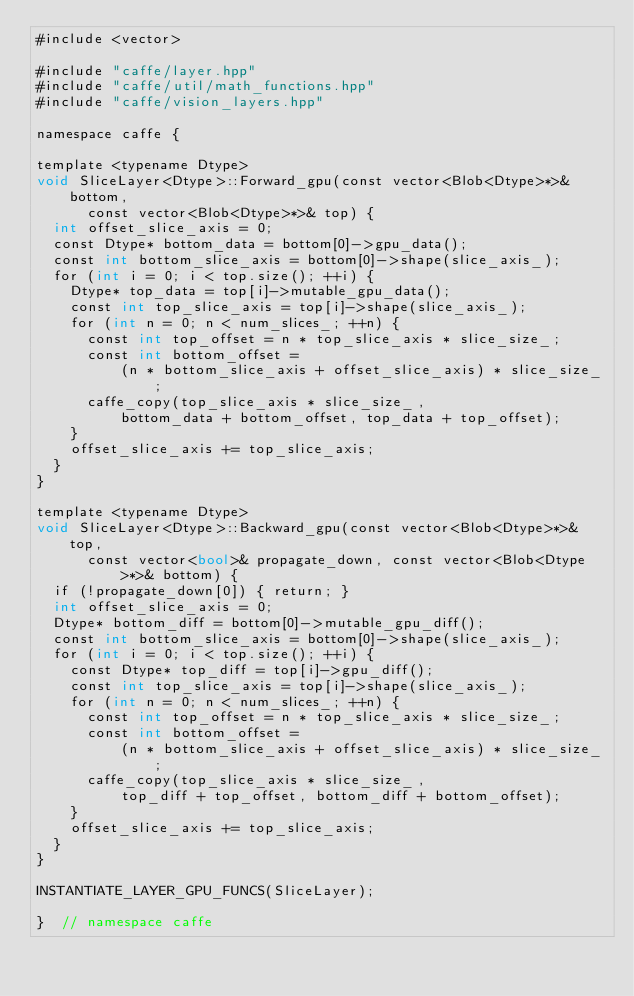Convert code to text. <code><loc_0><loc_0><loc_500><loc_500><_Cuda_>#include <vector>

#include "caffe/layer.hpp"
#include "caffe/util/math_functions.hpp"
#include "caffe/vision_layers.hpp"

namespace caffe {

template <typename Dtype>
void SliceLayer<Dtype>::Forward_gpu(const vector<Blob<Dtype>*>& bottom,
      const vector<Blob<Dtype>*>& top) {
  int offset_slice_axis = 0;
  const Dtype* bottom_data = bottom[0]->gpu_data();
  const int bottom_slice_axis = bottom[0]->shape(slice_axis_);
  for (int i = 0; i < top.size(); ++i) {
    Dtype* top_data = top[i]->mutable_gpu_data();
    const int top_slice_axis = top[i]->shape(slice_axis_);
    for (int n = 0; n < num_slices_; ++n) {
      const int top_offset = n * top_slice_axis * slice_size_;
      const int bottom_offset =
          (n * bottom_slice_axis + offset_slice_axis) * slice_size_;
      caffe_copy(top_slice_axis * slice_size_,
          bottom_data + bottom_offset, top_data + top_offset);
    }
    offset_slice_axis += top_slice_axis;
  }
}

template <typename Dtype>
void SliceLayer<Dtype>::Backward_gpu(const vector<Blob<Dtype>*>& top,
      const vector<bool>& propagate_down, const vector<Blob<Dtype>*>& bottom) {
  if (!propagate_down[0]) { return; }
  int offset_slice_axis = 0;
  Dtype* bottom_diff = bottom[0]->mutable_gpu_diff();
  const int bottom_slice_axis = bottom[0]->shape(slice_axis_);
  for (int i = 0; i < top.size(); ++i) {
    const Dtype* top_diff = top[i]->gpu_diff();
    const int top_slice_axis = top[i]->shape(slice_axis_);
    for (int n = 0; n < num_slices_; ++n) {
      const int top_offset = n * top_slice_axis * slice_size_;
      const int bottom_offset =
          (n * bottom_slice_axis + offset_slice_axis) * slice_size_;
      caffe_copy(top_slice_axis * slice_size_,
          top_diff + top_offset, bottom_diff + bottom_offset);
    }
    offset_slice_axis += top_slice_axis;
  }
}

INSTANTIATE_LAYER_GPU_FUNCS(SliceLayer);

}  // namespace caffe
</code> 